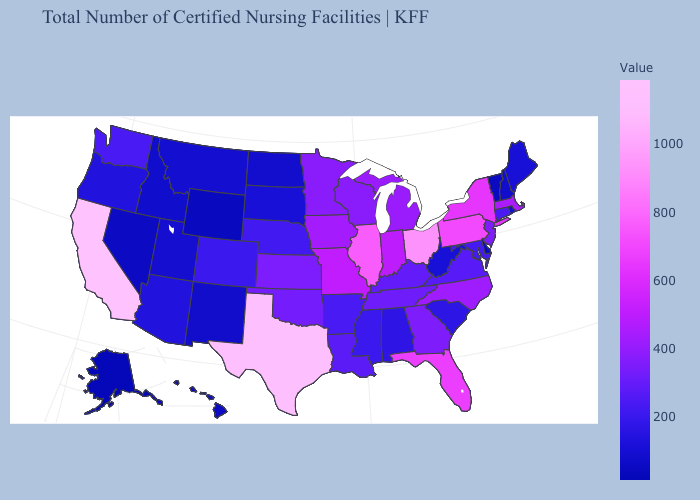Does Mississippi have a higher value than Hawaii?
Quick response, please. Yes. Among the states that border Wyoming , does Utah have the highest value?
Answer briefly. No. Among the states that border Arizona , does Utah have the lowest value?
Quick response, please. No. Which states have the lowest value in the Northeast?
Write a very short answer. Vermont. Among the states that border West Virginia , does Kentucky have the lowest value?
Answer briefly. No. Does Indiana have the lowest value in the USA?
Write a very short answer. No. 